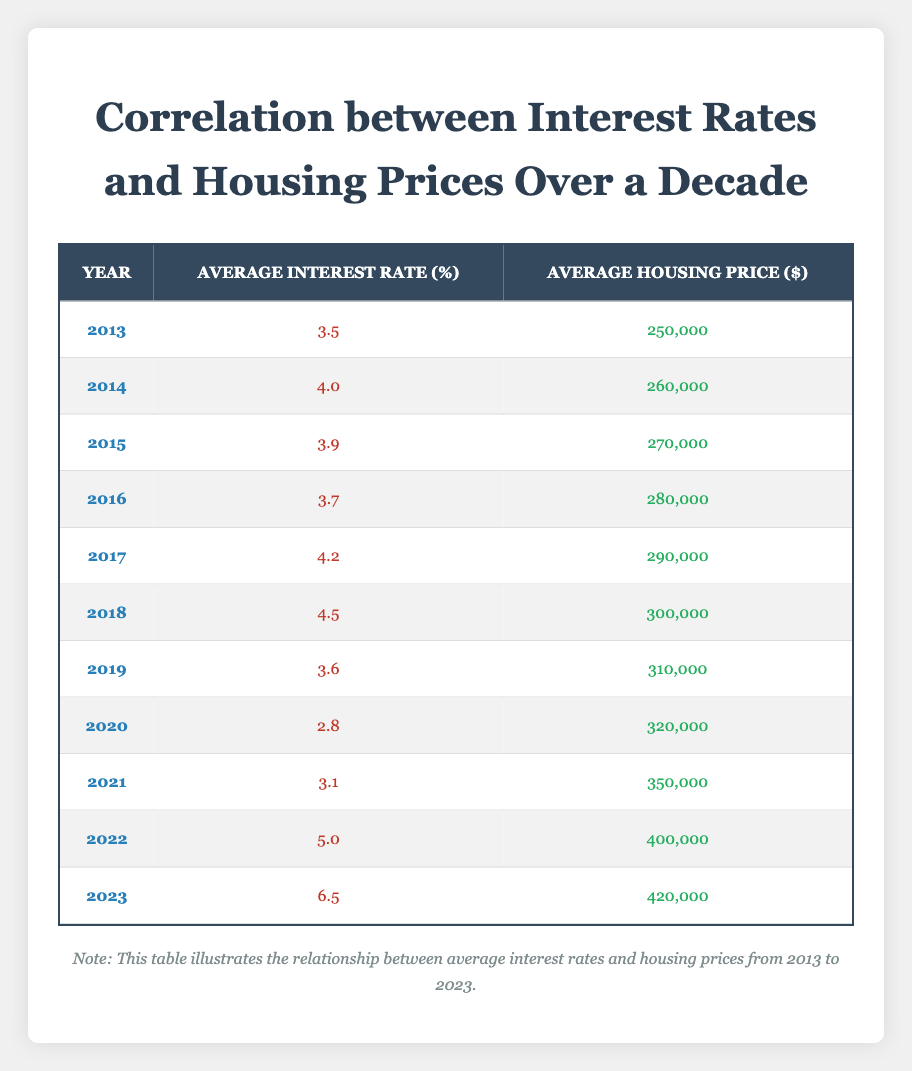What was the average housing price in 2019? In the table, the row for the year 2019 shows that the Average Housing Price was 310,000 dollars.
Answer: 310,000 Is there a year when the Average Interest Rate was at its lowest? Looking through the table, the lowest Average Interest Rate was 2.8 percent in 2020.
Answer: Yes What is the difference in Average Housing Price from 2013 to 2023? The Average Housing Price in 2013 was 250,000 dollars, and in 2023 it was 420,000 dollars. Therefore, the difference is 420,000 - 250,000 = 170,000 dollars.
Answer: 170,000 What was the Average Interest Rate in the year with the highest housing price? The highest Average Housing Price is in 2023 at 420,000 dollars. The Average Interest Rate for that year is 6.5 percent.
Answer: 6.5 Did the Average Interest Rate increase or decrease from 2021 to 2022? In 2021, the Average Interest Rate was 3.1 percent, which increased to 5.0 percent in 2022. Thus, there was an increase.
Answer: Increase What is the average of the Average Interest Rates from 2013 to 2023? To find the average, sum the Average Interest Rates from each year: (3.5 + 4.0 + 3.9 + 3.7 + 4.2 + 4.5 + 3.6 + 2.8 + 3.1 + 5.0 + 6.5) = 43.3. There are 11 years, so the average is 43.3 / 11 ≈ 3.93 percent.
Answer: 3.93 How much did the Average Housing Price increase between 2020 and 2021? The Average Housing Price in 2020 was 320,000 dollars, and it increased to 350,000 dollars in 2021. The increase is 350,000 - 320,000 = 30,000 dollars.
Answer: 30,000 Is the statement "The Average Interest Rate decreased from 2017 to 2018" true or false? Looking at the table, the Average Interest Rate in 2017 was 4.2 percent, and in 2018 it was 4.5 percent. Since it increased, the statement is false.
Answer: False 